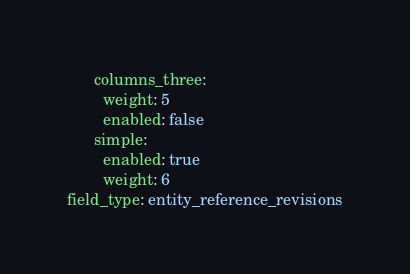<code> <loc_0><loc_0><loc_500><loc_500><_YAML_>      columns_three:
        weight: 5
        enabled: false
      simple:
        enabled: true
        weight: 6
field_type: entity_reference_revisions
</code> 